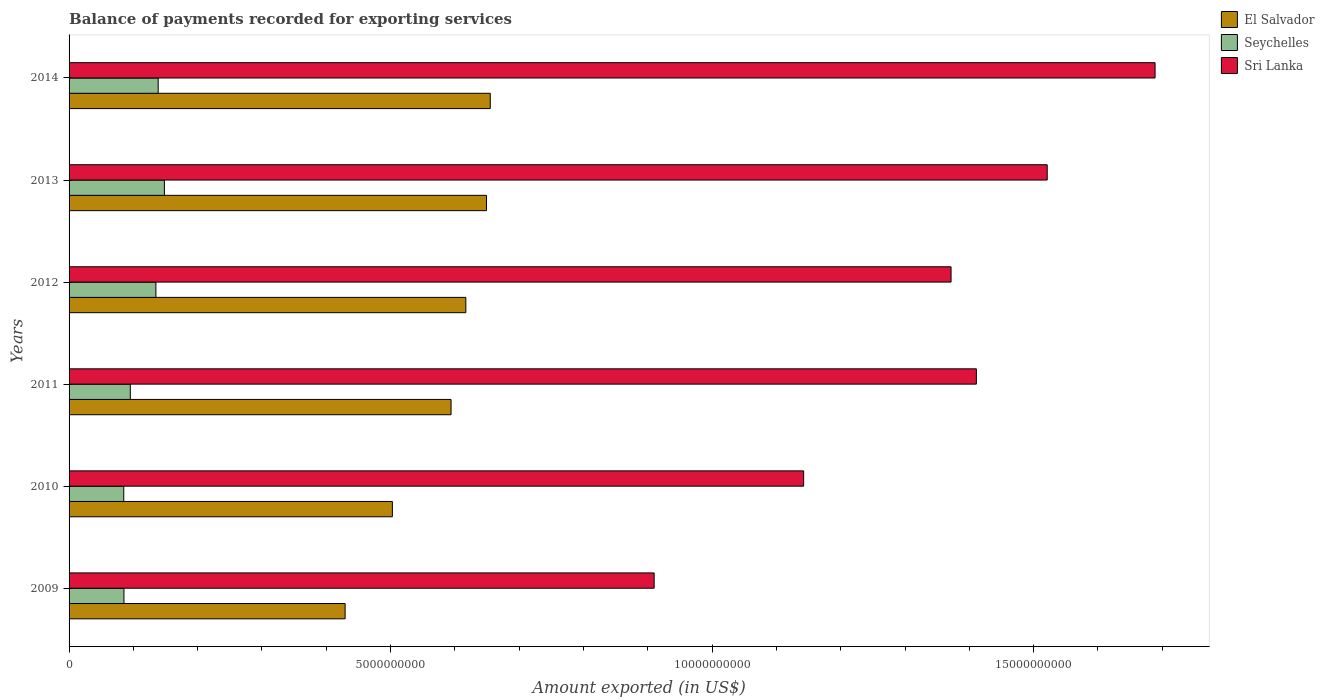How many groups of bars are there?
Provide a short and direct response. 6. Are the number of bars per tick equal to the number of legend labels?
Keep it short and to the point. Yes. Are the number of bars on each tick of the Y-axis equal?
Ensure brevity in your answer.  Yes. How many bars are there on the 6th tick from the bottom?
Give a very brief answer. 3. What is the label of the 2nd group of bars from the top?
Your response must be concise. 2013. In how many cases, is the number of bars for a given year not equal to the number of legend labels?
Offer a terse response. 0. What is the amount exported in Seychelles in 2010?
Provide a succinct answer. 8.50e+08. Across all years, what is the maximum amount exported in Sri Lanka?
Your response must be concise. 1.69e+1. Across all years, what is the minimum amount exported in Seychelles?
Offer a terse response. 8.50e+08. In which year was the amount exported in Sri Lanka maximum?
Offer a very short reply. 2014. In which year was the amount exported in Seychelles minimum?
Make the answer very short. 2010. What is the total amount exported in Sri Lanka in the graph?
Provide a succinct answer. 8.04e+1. What is the difference between the amount exported in El Salvador in 2009 and that in 2011?
Offer a very short reply. -1.65e+09. What is the difference between the amount exported in Sri Lanka in 2014 and the amount exported in Seychelles in 2012?
Offer a terse response. 1.55e+1. What is the average amount exported in El Salvador per year?
Keep it short and to the point. 5.75e+09. In the year 2011, what is the difference between the amount exported in El Salvador and amount exported in Sri Lanka?
Your answer should be compact. -8.17e+09. What is the ratio of the amount exported in Seychelles in 2009 to that in 2012?
Your answer should be compact. 0.63. Is the amount exported in Seychelles in 2009 less than that in 2014?
Your response must be concise. Yes. Is the difference between the amount exported in El Salvador in 2012 and 2013 greater than the difference between the amount exported in Sri Lanka in 2012 and 2013?
Your response must be concise. Yes. What is the difference between the highest and the second highest amount exported in El Salvador?
Give a very brief answer. 5.82e+07. What is the difference between the highest and the lowest amount exported in El Salvador?
Ensure brevity in your answer.  2.26e+09. Is the sum of the amount exported in Sri Lanka in 2012 and 2013 greater than the maximum amount exported in Seychelles across all years?
Your answer should be compact. Yes. What does the 2nd bar from the top in 2011 represents?
Make the answer very short. Seychelles. What does the 2nd bar from the bottom in 2009 represents?
Keep it short and to the point. Seychelles. Is it the case that in every year, the sum of the amount exported in El Salvador and amount exported in Seychelles is greater than the amount exported in Sri Lanka?
Offer a terse response. No. How many years are there in the graph?
Give a very brief answer. 6. Does the graph contain any zero values?
Your answer should be compact. No. Where does the legend appear in the graph?
Provide a succinct answer. Top right. How are the legend labels stacked?
Your answer should be compact. Vertical. What is the title of the graph?
Your answer should be very brief. Balance of payments recorded for exporting services. What is the label or title of the X-axis?
Offer a terse response. Amount exported (in US$). What is the label or title of the Y-axis?
Make the answer very short. Years. What is the Amount exported (in US$) in El Salvador in 2009?
Offer a very short reply. 4.29e+09. What is the Amount exported (in US$) of Seychelles in 2009?
Keep it short and to the point. 8.53e+08. What is the Amount exported (in US$) of Sri Lanka in 2009?
Provide a short and direct response. 9.10e+09. What is the Amount exported (in US$) in El Salvador in 2010?
Make the answer very short. 5.03e+09. What is the Amount exported (in US$) in Seychelles in 2010?
Offer a very short reply. 8.50e+08. What is the Amount exported (in US$) of Sri Lanka in 2010?
Provide a short and direct response. 1.14e+1. What is the Amount exported (in US$) of El Salvador in 2011?
Offer a very short reply. 5.94e+09. What is the Amount exported (in US$) in Seychelles in 2011?
Your answer should be very brief. 9.52e+08. What is the Amount exported (in US$) of Sri Lanka in 2011?
Provide a short and direct response. 1.41e+1. What is the Amount exported (in US$) in El Salvador in 2012?
Your response must be concise. 6.17e+09. What is the Amount exported (in US$) of Seychelles in 2012?
Your answer should be very brief. 1.35e+09. What is the Amount exported (in US$) of Sri Lanka in 2012?
Your response must be concise. 1.37e+1. What is the Amount exported (in US$) of El Salvador in 2013?
Provide a short and direct response. 6.49e+09. What is the Amount exported (in US$) in Seychelles in 2013?
Make the answer very short. 1.48e+09. What is the Amount exported (in US$) of Sri Lanka in 2013?
Offer a very short reply. 1.52e+1. What is the Amount exported (in US$) of El Salvador in 2014?
Provide a succinct answer. 6.55e+09. What is the Amount exported (in US$) in Seychelles in 2014?
Your answer should be very brief. 1.39e+09. What is the Amount exported (in US$) in Sri Lanka in 2014?
Make the answer very short. 1.69e+1. Across all years, what is the maximum Amount exported (in US$) in El Salvador?
Ensure brevity in your answer.  6.55e+09. Across all years, what is the maximum Amount exported (in US$) of Seychelles?
Provide a succinct answer. 1.48e+09. Across all years, what is the maximum Amount exported (in US$) in Sri Lanka?
Offer a very short reply. 1.69e+1. Across all years, what is the minimum Amount exported (in US$) of El Salvador?
Give a very brief answer. 4.29e+09. Across all years, what is the minimum Amount exported (in US$) of Seychelles?
Make the answer very short. 8.50e+08. Across all years, what is the minimum Amount exported (in US$) of Sri Lanka?
Your answer should be very brief. 9.10e+09. What is the total Amount exported (in US$) in El Salvador in the graph?
Give a very brief answer. 3.45e+1. What is the total Amount exported (in US$) of Seychelles in the graph?
Offer a terse response. 6.87e+09. What is the total Amount exported (in US$) of Sri Lanka in the graph?
Keep it short and to the point. 8.04e+1. What is the difference between the Amount exported (in US$) in El Salvador in 2009 and that in 2010?
Keep it short and to the point. -7.35e+08. What is the difference between the Amount exported (in US$) of Seychelles in 2009 and that in 2010?
Keep it short and to the point. 3.12e+06. What is the difference between the Amount exported (in US$) in Sri Lanka in 2009 and that in 2010?
Give a very brief answer. -2.32e+09. What is the difference between the Amount exported (in US$) of El Salvador in 2009 and that in 2011?
Make the answer very short. -1.65e+09. What is the difference between the Amount exported (in US$) in Seychelles in 2009 and that in 2011?
Offer a very short reply. -9.90e+07. What is the difference between the Amount exported (in US$) in Sri Lanka in 2009 and that in 2011?
Give a very brief answer. -5.01e+09. What is the difference between the Amount exported (in US$) in El Salvador in 2009 and that in 2012?
Give a very brief answer. -1.88e+09. What is the difference between the Amount exported (in US$) in Seychelles in 2009 and that in 2012?
Your answer should be very brief. -4.97e+08. What is the difference between the Amount exported (in US$) in Sri Lanka in 2009 and that in 2012?
Provide a succinct answer. -4.62e+09. What is the difference between the Amount exported (in US$) of El Salvador in 2009 and that in 2013?
Your response must be concise. -2.20e+09. What is the difference between the Amount exported (in US$) in Seychelles in 2009 and that in 2013?
Offer a terse response. -6.29e+08. What is the difference between the Amount exported (in US$) of Sri Lanka in 2009 and that in 2013?
Give a very brief answer. -6.11e+09. What is the difference between the Amount exported (in US$) of El Salvador in 2009 and that in 2014?
Provide a short and direct response. -2.26e+09. What is the difference between the Amount exported (in US$) of Seychelles in 2009 and that in 2014?
Give a very brief answer. -5.32e+08. What is the difference between the Amount exported (in US$) of Sri Lanka in 2009 and that in 2014?
Ensure brevity in your answer.  -7.79e+09. What is the difference between the Amount exported (in US$) of El Salvador in 2010 and that in 2011?
Offer a very short reply. -9.13e+08. What is the difference between the Amount exported (in US$) of Seychelles in 2010 and that in 2011?
Provide a short and direct response. -1.02e+08. What is the difference between the Amount exported (in US$) of Sri Lanka in 2010 and that in 2011?
Your answer should be compact. -2.69e+09. What is the difference between the Amount exported (in US$) of El Salvador in 2010 and that in 2012?
Your answer should be compact. -1.14e+09. What is the difference between the Amount exported (in US$) of Seychelles in 2010 and that in 2012?
Keep it short and to the point. -5.00e+08. What is the difference between the Amount exported (in US$) in Sri Lanka in 2010 and that in 2012?
Provide a succinct answer. -2.29e+09. What is the difference between the Amount exported (in US$) in El Salvador in 2010 and that in 2013?
Offer a very short reply. -1.46e+09. What is the difference between the Amount exported (in US$) in Seychelles in 2010 and that in 2013?
Your answer should be compact. -6.32e+08. What is the difference between the Amount exported (in US$) of Sri Lanka in 2010 and that in 2013?
Keep it short and to the point. -3.79e+09. What is the difference between the Amount exported (in US$) in El Salvador in 2010 and that in 2014?
Your answer should be very brief. -1.52e+09. What is the difference between the Amount exported (in US$) of Seychelles in 2010 and that in 2014?
Ensure brevity in your answer.  -5.35e+08. What is the difference between the Amount exported (in US$) in Sri Lanka in 2010 and that in 2014?
Provide a succinct answer. -5.47e+09. What is the difference between the Amount exported (in US$) in El Salvador in 2011 and that in 2012?
Your answer should be very brief. -2.30e+08. What is the difference between the Amount exported (in US$) of Seychelles in 2011 and that in 2012?
Your answer should be very brief. -3.98e+08. What is the difference between the Amount exported (in US$) in Sri Lanka in 2011 and that in 2012?
Offer a terse response. 3.94e+08. What is the difference between the Amount exported (in US$) in El Salvador in 2011 and that in 2013?
Offer a very short reply. -5.51e+08. What is the difference between the Amount exported (in US$) of Seychelles in 2011 and that in 2013?
Your response must be concise. -5.30e+08. What is the difference between the Amount exported (in US$) of Sri Lanka in 2011 and that in 2013?
Keep it short and to the point. -1.10e+09. What is the difference between the Amount exported (in US$) in El Salvador in 2011 and that in 2014?
Make the answer very short. -6.10e+08. What is the difference between the Amount exported (in US$) of Seychelles in 2011 and that in 2014?
Ensure brevity in your answer.  -4.33e+08. What is the difference between the Amount exported (in US$) in Sri Lanka in 2011 and that in 2014?
Your response must be concise. -2.78e+09. What is the difference between the Amount exported (in US$) in El Salvador in 2012 and that in 2013?
Your response must be concise. -3.22e+08. What is the difference between the Amount exported (in US$) in Seychelles in 2012 and that in 2013?
Make the answer very short. -1.32e+08. What is the difference between the Amount exported (in US$) in Sri Lanka in 2012 and that in 2013?
Offer a terse response. -1.50e+09. What is the difference between the Amount exported (in US$) of El Salvador in 2012 and that in 2014?
Your answer should be compact. -3.80e+08. What is the difference between the Amount exported (in US$) in Seychelles in 2012 and that in 2014?
Provide a short and direct response. -3.55e+07. What is the difference between the Amount exported (in US$) of Sri Lanka in 2012 and that in 2014?
Ensure brevity in your answer.  -3.17e+09. What is the difference between the Amount exported (in US$) of El Salvador in 2013 and that in 2014?
Offer a terse response. -5.82e+07. What is the difference between the Amount exported (in US$) in Seychelles in 2013 and that in 2014?
Make the answer very short. 9.66e+07. What is the difference between the Amount exported (in US$) in Sri Lanka in 2013 and that in 2014?
Your answer should be very brief. -1.68e+09. What is the difference between the Amount exported (in US$) of El Salvador in 2009 and the Amount exported (in US$) of Seychelles in 2010?
Keep it short and to the point. 3.44e+09. What is the difference between the Amount exported (in US$) of El Salvador in 2009 and the Amount exported (in US$) of Sri Lanka in 2010?
Your answer should be very brief. -7.13e+09. What is the difference between the Amount exported (in US$) in Seychelles in 2009 and the Amount exported (in US$) in Sri Lanka in 2010?
Keep it short and to the point. -1.06e+1. What is the difference between the Amount exported (in US$) of El Salvador in 2009 and the Amount exported (in US$) of Seychelles in 2011?
Your answer should be compact. 3.34e+09. What is the difference between the Amount exported (in US$) in El Salvador in 2009 and the Amount exported (in US$) in Sri Lanka in 2011?
Your response must be concise. -9.82e+09. What is the difference between the Amount exported (in US$) of Seychelles in 2009 and the Amount exported (in US$) of Sri Lanka in 2011?
Provide a short and direct response. -1.33e+1. What is the difference between the Amount exported (in US$) of El Salvador in 2009 and the Amount exported (in US$) of Seychelles in 2012?
Give a very brief answer. 2.94e+09. What is the difference between the Amount exported (in US$) in El Salvador in 2009 and the Amount exported (in US$) in Sri Lanka in 2012?
Give a very brief answer. -9.42e+09. What is the difference between the Amount exported (in US$) in Seychelles in 2009 and the Amount exported (in US$) in Sri Lanka in 2012?
Your answer should be very brief. -1.29e+1. What is the difference between the Amount exported (in US$) of El Salvador in 2009 and the Amount exported (in US$) of Seychelles in 2013?
Keep it short and to the point. 2.81e+09. What is the difference between the Amount exported (in US$) of El Salvador in 2009 and the Amount exported (in US$) of Sri Lanka in 2013?
Ensure brevity in your answer.  -1.09e+1. What is the difference between the Amount exported (in US$) in Seychelles in 2009 and the Amount exported (in US$) in Sri Lanka in 2013?
Provide a succinct answer. -1.44e+1. What is the difference between the Amount exported (in US$) in El Salvador in 2009 and the Amount exported (in US$) in Seychelles in 2014?
Your answer should be very brief. 2.91e+09. What is the difference between the Amount exported (in US$) in El Salvador in 2009 and the Amount exported (in US$) in Sri Lanka in 2014?
Make the answer very short. -1.26e+1. What is the difference between the Amount exported (in US$) of Seychelles in 2009 and the Amount exported (in US$) of Sri Lanka in 2014?
Make the answer very short. -1.60e+1. What is the difference between the Amount exported (in US$) in El Salvador in 2010 and the Amount exported (in US$) in Seychelles in 2011?
Offer a terse response. 4.08e+09. What is the difference between the Amount exported (in US$) in El Salvador in 2010 and the Amount exported (in US$) in Sri Lanka in 2011?
Offer a terse response. -9.08e+09. What is the difference between the Amount exported (in US$) in Seychelles in 2010 and the Amount exported (in US$) in Sri Lanka in 2011?
Your answer should be very brief. -1.33e+1. What is the difference between the Amount exported (in US$) in El Salvador in 2010 and the Amount exported (in US$) in Seychelles in 2012?
Make the answer very short. 3.68e+09. What is the difference between the Amount exported (in US$) in El Salvador in 2010 and the Amount exported (in US$) in Sri Lanka in 2012?
Provide a succinct answer. -8.69e+09. What is the difference between the Amount exported (in US$) in Seychelles in 2010 and the Amount exported (in US$) in Sri Lanka in 2012?
Your answer should be very brief. -1.29e+1. What is the difference between the Amount exported (in US$) of El Salvador in 2010 and the Amount exported (in US$) of Seychelles in 2013?
Your answer should be compact. 3.55e+09. What is the difference between the Amount exported (in US$) in El Salvador in 2010 and the Amount exported (in US$) in Sri Lanka in 2013?
Make the answer very short. -1.02e+1. What is the difference between the Amount exported (in US$) in Seychelles in 2010 and the Amount exported (in US$) in Sri Lanka in 2013?
Ensure brevity in your answer.  -1.44e+1. What is the difference between the Amount exported (in US$) in El Salvador in 2010 and the Amount exported (in US$) in Seychelles in 2014?
Keep it short and to the point. 3.64e+09. What is the difference between the Amount exported (in US$) in El Salvador in 2010 and the Amount exported (in US$) in Sri Lanka in 2014?
Ensure brevity in your answer.  -1.19e+1. What is the difference between the Amount exported (in US$) of Seychelles in 2010 and the Amount exported (in US$) of Sri Lanka in 2014?
Your answer should be very brief. -1.60e+1. What is the difference between the Amount exported (in US$) in El Salvador in 2011 and the Amount exported (in US$) in Seychelles in 2012?
Offer a very short reply. 4.59e+09. What is the difference between the Amount exported (in US$) of El Salvador in 2011 and the Amount exported (in US$) of Sri Lanka in 2012?
Give a very brief answer. -7.78e+09. What is the difference between the Amount exported (in US$) of Seychelles in 2011 and the Amount exported (in US$) of Sri Lanka in 2012?
Offer a very short reply. -1.28e+1. What is the difference between the Amount exported (in US$) of El Salvador in 2011 and the Amount exported (in US$) of Seychelles in 2013?
Provide a short and direct response. 4.46e+09. What is the difference between the Amount exported (in US$) in El Salvador in 2011 and the Amount exported (in US$) in Sri Lanka in 2013?
Keep it short and to the point. -9.27e+09. What is the difference between the Amount exported (in US$) of Seychelles in 2011 and the Amount exported (in US$) of Sri Lanka in 2013?
Make the answer very short. -1.43e+1. What is the difference between the Amount exported (in US$) of El Salvador in 2011 and the Amount exported (in US$) of Seychelles in 2014?
Give a very brief answer. 4.55e+09. What is the difference between the Amount exported (in US$) of El Salvador in 2011 and the Amount exported (in US$) of Sri Lanka in 2014?
Provide a short and direct response. -1.09e+1. What is the difference between the Amount exported (in US$) of Seychelles in 2011 and the Amount exported (in US$) of Sri Lanka in 2014?
Your answer should be compact. -1.59e+1. What is the difference between the Amount exported (in US$) in El Salvador in 2012 and the Amount exported (in US$) in Seychelles in 2013?
Your response must be concise. 4.69e+09. What is the difference between the Amount exported (in US$) in El Salvador in 2012 and the Amount exported (in US$) in Sri Lanka in 2013?
Your answer should be very brief. -9.04e+09. What is the difference between the Amount exported (in US$) in Seychelles in 2012 and the Amount exported (in US$) in Sri Lanka in 2013?
Your answer should be very brief. -1.39e+1. What is the difference between the Amount exported (in US$) in El Salvador in 2012 and the Amount exported (in US$) in Seychelles in 2014?
Your answer should be very brief. 4.78e+09. What is the difference between the Amount exported (in US$) in El Salvador in 2012 and the Amount exported (in US$) in Sri Lanka in 2014?
Offer a terse response. -1.07e+1. What is the difference between the Amount exported (in US$) in Seychelles in 2012 and the Amount exported (in US$) in Sri Lanka in 2014?
Offer a very short reply. -1.55e+1. What is the difference between the Amount exported (in US$) in El Salvador in 2013 and the Amount exported (in US$) in Seychelles in 2014?
Your answer should be very brief. 5.11e+09. What is the difference between the Amount exported (in US$) of El Salvador in 2013 and the Amount exported (in US$) of Sri Lanka in 2014?
Provide a short and direct response. -1.04e+1. What is the difference between the Amount exported (in US$) of Seychelles in 2013 and the Amount exported (in US$) of Sri Lanka in 2014?
Keep it short and to the point. -1.54e+1. What is the average Amount exported (in US$) in El Salvador per year?
Your response must be concise. 5.75e+09. What is the average Amount exported (in US$) in Seychelles per year?
Provide a short and direct response. 1.15e+09. What is the average Amount exported (in US$) in Sri Lanka per year?
Offer a very short reply. 1.34e+1. In the year 2009, what is the difference between the Amount exported (in US$) in El Salvador and Amount exported (in US$) in Seychelles?
Keep it short and to the point. 3.44e+09. In the year 2009, what is the difference between the Amount exported (in US$) of El Salvador and Amount exported (in US$) of Sri Lanka?
Ensure brevity in your answer.  -4.81e+09. In the year 2009, what is the difference between the Amount exported (in US$) of Seychelles and Amount exported (in US$) of Sri Lanka?
Offer a very short reply. -8.25e+09. In the year 2010, what is the difference between the Amount exported (in US$) in El Salvador and Amount exported (in US$) in Seychelles?
Your response must be concise. 4.18e+09. In the year 2010, what is the difference between the Amount exported (in US$) in El Salvador and Amount exported (in US$) in Sri Lanka?
Give a very brief answer. -6.40e+09. In the year 2010, what is the difference between the Amount exported (in US$) in Seychelles and Amount exported (in US$) in Sri Lanka?
Your answer should be very brief. -1.06e+1. In the year 2011, what is the difference between the Amount exported (in US$) of El Salvador and Amount exported (in US$) of Seychelles?
Provide a succinct answer. 4.99e+09. In the year 2011, what is the difference between the Amount exported (in US$) in El Salvador and Amount exported (in US$) in Sri Lanka?
Make the answer very short. -8.17e+09. In the year 2011, what is the difference between the Amount exported (in US$) in Seychelles and Amount exported (in US$) in Sri Lanka?
Make the answer very short. -1.32e+1. In the year 2012, what is the difference between the Amount exported (in US$) in El Salvador and Amount exported (in US$) in Seychelles?
Ensure brevity in your answer.  4.82e+09. In the year 2012, what is the difference between the Amount exported (in US$) in El Salvador and Amount exported (in US$) in Sri Lanka?
Give a very brief answer. -7.55e+09. In the year 2012, what is the difference between the Amount exported (in US$) in Seychelles and Amount exported (in US$) in Sri Lanka?
Provide a succinct answer. -1.24e+1. In the year 2013, what is the difference between the Amount exported (in US$) of El Salvador and Amount exported (in US$) of Seychelles?
Ensure brevity in your answer.  5.01e+09. In the year 2013, what is the difference between the Amount exported (in US$) in El Salvador and Amount exported (in US$) in Sri Lanka?
Ensure brevity in your answer.  -8.72e+09. In the year 2013, what is the difference between the Amount exported (in US$) in Seychelles and Amount exported (in US$) in Sri Lanka?
Ensure brevity in your answer.  -1.37e+1. In the year 2014, what is the difference between the Amount exported (in US$) in El Salvador and Amount exported (in US$) in Seychelles?
Your answer should be very brief. 5.16e+09. In the year 2014, what is the difference between the Amount exported (in US$) of El Salvador and Amount exported (in US$) of Sri Lanka?
Offer a very short reply. -1.03e+1. In the year 2014, what is the difference between the Amount exported (in US$) of Seychelles and Amount exported (in US$) of Sri Lanka?
Keep it short and to the point. -1.55e+1. What is the ratio of the Amount exported (in US$) of El Salvador in 2009 to that in 2010?
Give a very brief answer. 0.85. What is the ratio of the Amount exported (in US$) of Sri Lanka in 2009 to that in 2010?
Your response must be concise. 0.8. What is the ratio of the Amount exported (in US$) of El Salvador in 2009 to that in 2011?
Offer a very short reply. 0.72. What is the ratio of the Amount exported (in US$) in Seychelles in 2009 to that in 2011?
Offer a terse response. 0.9. What is the ratio of the Amount exported (in US$) of Sri Lanka in 2009 to that in 2011?
Give a very brief answer. 0.64. What is the ratio of the Amount exported (in US$) of El Salvador in 2009 to that in 2012?
Your answer should be very brief. 0.7. What is the ratio of the Amount exported (in US$) in Seychelles in 2009 to that in 2012?
Offer a terse response. 0.63. What is the ratio of the Amount exported (in US$) in Sri Lanka in 2009 to that in 2012?
Offer a very short reply. 0.66. What is the ratio of the Amount exported (in US$) of El Salvador in 2009 to that in 2013?
Ensure brevity in your answer.  0.66. What is the ratio of the Amount exported (in US$) of Seychelles in 2009 to that in 2013?
Provide a succinct answer. 0.58. What is the ratio of the Amount exported (in US$) in Sri Lanka in 2009 to that in 2013?
Keep it short and to the point. 0.6. What is the ratio of the Amount exported (in US$) in El Salvador in 2009 to that in 2014?
Your answer should be compact. 0.66. What is the ratio of the Amount exported (in US$) in Seychelles in 2009 to that in 2014?
Offer a terse response. 0.62. What is the ratio of the Amount exported (in US$) in Sri Lanka in 2009 to that in 2014?
Provide a succinct answer. 0.54. What is the ratio of the Amount exported (in US$) of El Salvador in 2010 to that in 2011?
Your response must be concise. 0.85. What is the ratio of the Amount exported (in US$) of Seychelles in 2010 to that in 2011?
Give a very brief answer. 0.89. What is the ratio of the Amount exported (in US$) in Sri Lanka in 2010 to that in 2011?
Your answer should be compact. 0.81. What is the ratio of the Amount exported (in US$) in El Salvador in 2010 to that in 2012?
Keep it short and to the point. 0.81. What is the ratio of the Amount exported (in US$) in Seychelles in 2010 to that in 2012?
Provide a short and direct response. 0.63. What is the ratio of the Amount exported (in US$) in Sri Lanka in 2010 to that in 2012?
Your answer should be compact. 0.83. What is the ratio of the Amount exported (in US$) in El Salvador in 2010 to that in 2013?
Offer a terse response. 0.77. What is the ratio of the Amount exported (in US$) of Seychelles in 2010 to that in 2013?
Your answer should be compact. 0.57. What is the ratio of the Amount exported (in US$) in Sri Lanka in 2010 to that in 2013?
Make the answer very short. 0.75. What is the ratio of the Amount exported (in US$) in El Salvador in 2010 to that in 2014?
Your answer should be compact. 0.77. What is the ratio of the Amount exported (in US$) in Seychelles in 2010 to that in 2014?
Offer a terse response. 0.61. What is the ratio of the Amount exported (in US$) in Sri Lanka in 2010 to that in 2014?
Provide a succinct answer. 0.68. What is the ratio of the Amount exported (in US$) in El Salvador in 2011 to that in 2012?
Offer a terse response. 0.96. What is the ratio of the Amount exported (in US$) of Seychelles in 2011 to that in 2012?
Your answer should be very brief. 0.71. What is the ratio of the Amount exported (in US$) in Sri Lanka in 2011 to that in 2012?
Offer a very short reply. 1.03. What is the ratio of the Amount exported (in US$) in El Salvador in 2011 to that in 2013?
Offer a very short reply. 0.92. What is the ratio of the Amount exported (in US$) in Seychelles in 2011 to that in 2013?
Your response must be concise. 0.64. What is the ratio of the Amount exported (in US$) in Sri Lanka in 2011 to that in 2013?
Your response must be concise. 0.93. What is the ratio of the Amount exported (in US$) of El Salvador in 2011 to that in 2014?
Provide a short and direct response. 0.91. What is the ratio of the Amount exported (in US$) in Seychelles in 2011 to that in 2014?
Keep it short and to the point. 0.69. What is the ratio of the Amount exported (in US$) in Sri Lanka in 2011 to that in 2014?
Offer a very short reply. 0.84. What is the ratio of the Amount exported (in US$) of El Salvador in 2012 to that in 2013?
Your response must be concise. 0.95. What is the ratio of the Amount exported (in US$) in Seychelles in 2012 to that in 2013?
Provide a succinct answer. 0.91. What is the ratio of the Amount exported (in US$) of Sri Lanka in 2012 to that in 2013?
Keep it short and to the point. 0.9. What is the ratio of the Amount exported (in US$) in El Salvador in 2012 to that in 2014?
Keep it short and to the point. 0.94. What is the ratio of the Amount exported (in US$) in Seychelles in 2012 to that in 2014?
Give a very brief answer. 0.97. What is the ratio of the Amount exported (in US$) in Sri Lanka in 2012 to that in 2014?
Ensure brevity in your answer.  0.81. What is the ratio of the Amount exported (in US$) of Seychelles in 2013 to that in 2014?
Provide a short and direct response. 1.07. What is the ratio of the Amount exported (in US$) in Sri Lanka in 2013 to that in 2014?
Ensure brevity in your answer.  0.9. What is the difference between the highest and the second highest Amount exported (in US$) in El Salvador?
Provide a succinct answer. 5.82e+07. What is the difference between the highest and the second highest Amount exported (in US$) in Seychelles?
Offer a terse response. 9.66e+07. What is the difference between the highest and the second highest Amount exported (in US$) of Sri Lanka?
Keep it short and to the point. 1.68e+09. What is the difference between the highest and the lowest Amount exported (in US$) in El Salvador?
Your answer should be very brief. 2.26e+09. What is the difference between the highest and the lowest Amount exported (in US$) in Seychelles?
Give a very brief answer. 6.32e+08. What is the difference between the highest and the lowest Amount exported (in US$) of Sri Lanka?
Provide a short and direct response. 7.79e+09. 